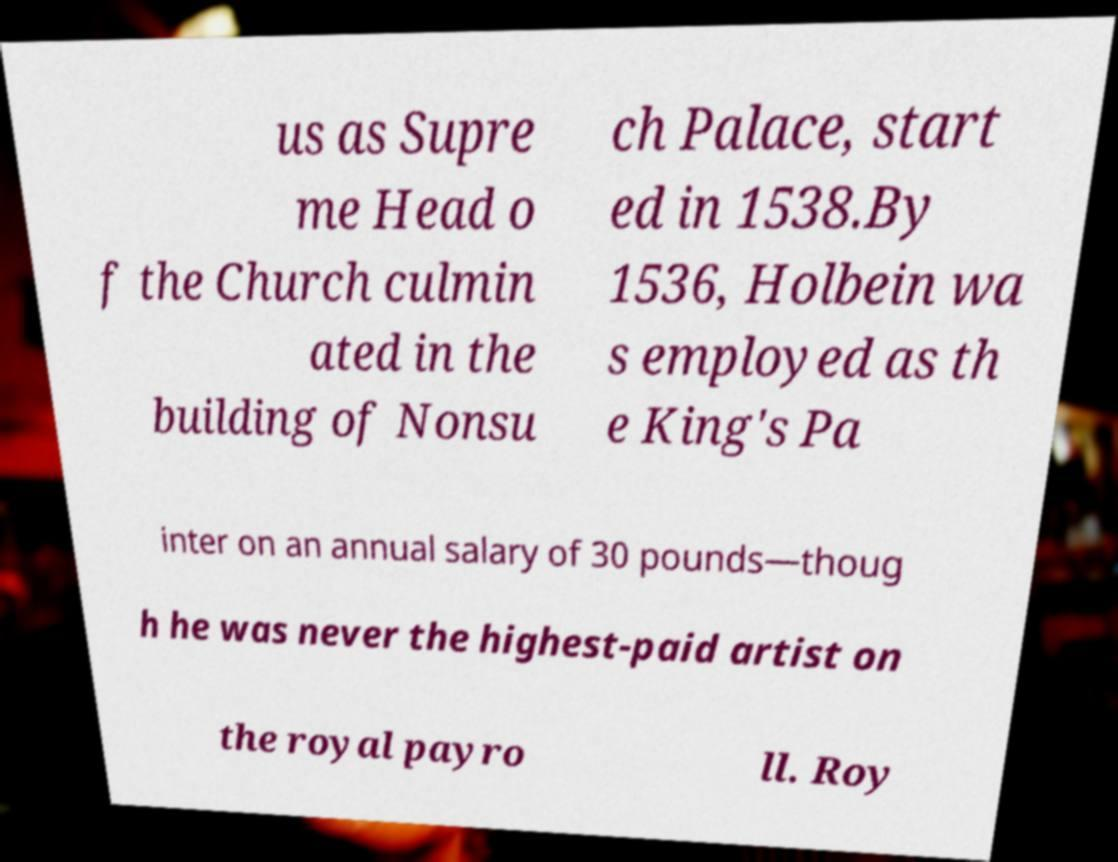Please identify and transcribe the text found in this image. us as Supre me Head o f the Church culmin ated in the building of Nonsu ch Palace, start ed in 1538.By 1536, Holbein wa s employed as th e King's Pa inter on an annual salary of 30 pounds—thoug h he was never the highest-paid artist on the royal payro ll. Roy 